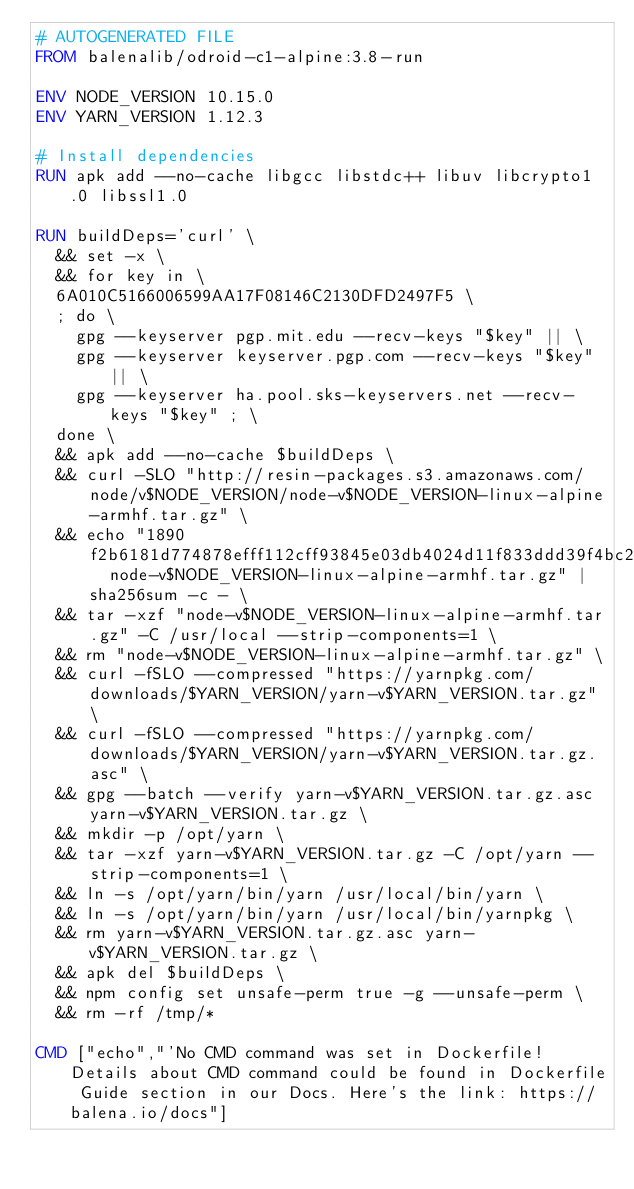<code> <loc_0><loc_0><loc_500><loc_500><_Dockerfile_># AUTOGENERATED FILE
FROM balenalib/odroid-c1-alpine:3.8-run

ENV NODE_VERSION 10.15.0
ENV YARN_VERSION 1.12.3

# Install dependencies
RUN apk add --no-cache libgcc libstdc++ libuv libcrypto1.0 libssl1.0

RUN buildDeps='curl' \
	&& set -x \
	&& for key in \
	6A010C5166006599AA17F08146C2130DFD2497F5 \
	; do \
		gpg --keyserver pgp.mit.edu --recv-keys "$key" || \
		gpg --keyserver keyserver.pgp.com --recv-keys "$key" || \
		gpg --keyserver ha.pool.sks-keyservers.net --recv-keys "$key" ; \
	done \
	&& apk add --no-cache $buildDeps \
	&& curl -SLO "http://resin-packages.s3.amazonaws.com/node/v$NODE_VERSION/node-v$NODE_VERSION-linux-alpine-armhf.tar.gz" \
	&& echo "1890f2b6181d774878efff112cff93845e03db4024d11f833ddd39f4bc21a983  node-v$NODE_VERSION-linux-alpine-armhf.tar.gz" | sha256sum -c - \
	&& tar -xzf "node-v$NODE_VERSION-linux-alpine-armhf.tar.gz" -C /usr/local --strip-components=1 \
	&& rm "node-v$NODE_VERSION-linux-alpine-armhf.tar.gz" \
	&& curl -fSLO --compressed "https://yarnpkg.com/downloads/$YARN_VERSION/yarn-v$YARN_VERSION.tar.gz" \
	&& curl -fSLO --compressed "https://yarnpkg.com/downloads/$YARN_VERSION/yarn-v$YARN_VERSION.tar.gz.asc" \
	&& gpg --batch --verify yarn-v$YARN_VERSION.tar.gz.asc yarn-v$YARN_VERSION.tar.gz \
	&& mkdir -p /opt/yarn \
	&& tar -xzf yarn-v$YARN_VERSION.tar.gz -C /opt/yarn --strip-components=1 \
	&& ln -s /opt/yarn/bin/yarn /usr/local/bin/yarn \
	&& ln -s /opt/yarn/bin/yarn /usr/local/bin/yarnpkg \
	&& rm yarn-v$YARN_VERSION.tar.gz.asc yarn-v$YARN_VERSION.tar.gz \
	&& apk del $buildDeps \
	&& npm config set unsafe-perm true -g --unsafe-perm \
	&& rm -rf /tmp/*

CMD ["echo","'No CMD command was set in Dockerfile! Details about CMD command could be found in Dockerfile Guide section in our Docs. Here's the link: https://balena.io/docs"]</code> 